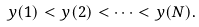Convert formula to latex. <formula><loc_0><loc_0><loc_500><loc_500>y ( 1 ) < y ( 2 ) < \cdots < y ( N ) .</formula> 